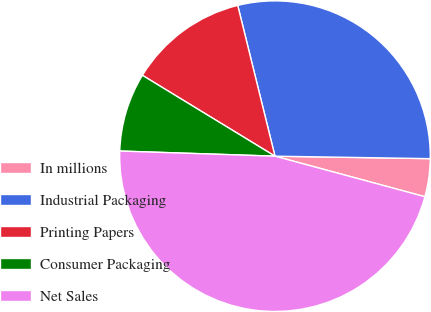Convert chart. <chart><loc_0><loc_0><loc_500><loc_500><pie_chart><fcel>In millions<fcel>Industrial Packaging<fcel>Printing Papers<fcel>Consumer Packaging<fcel>Net Sales<nl><fcel>3.95%<fcel>29.11%<fcel>12.43%<fcel>8.19%<fcel>46.33%<nl></chart> 